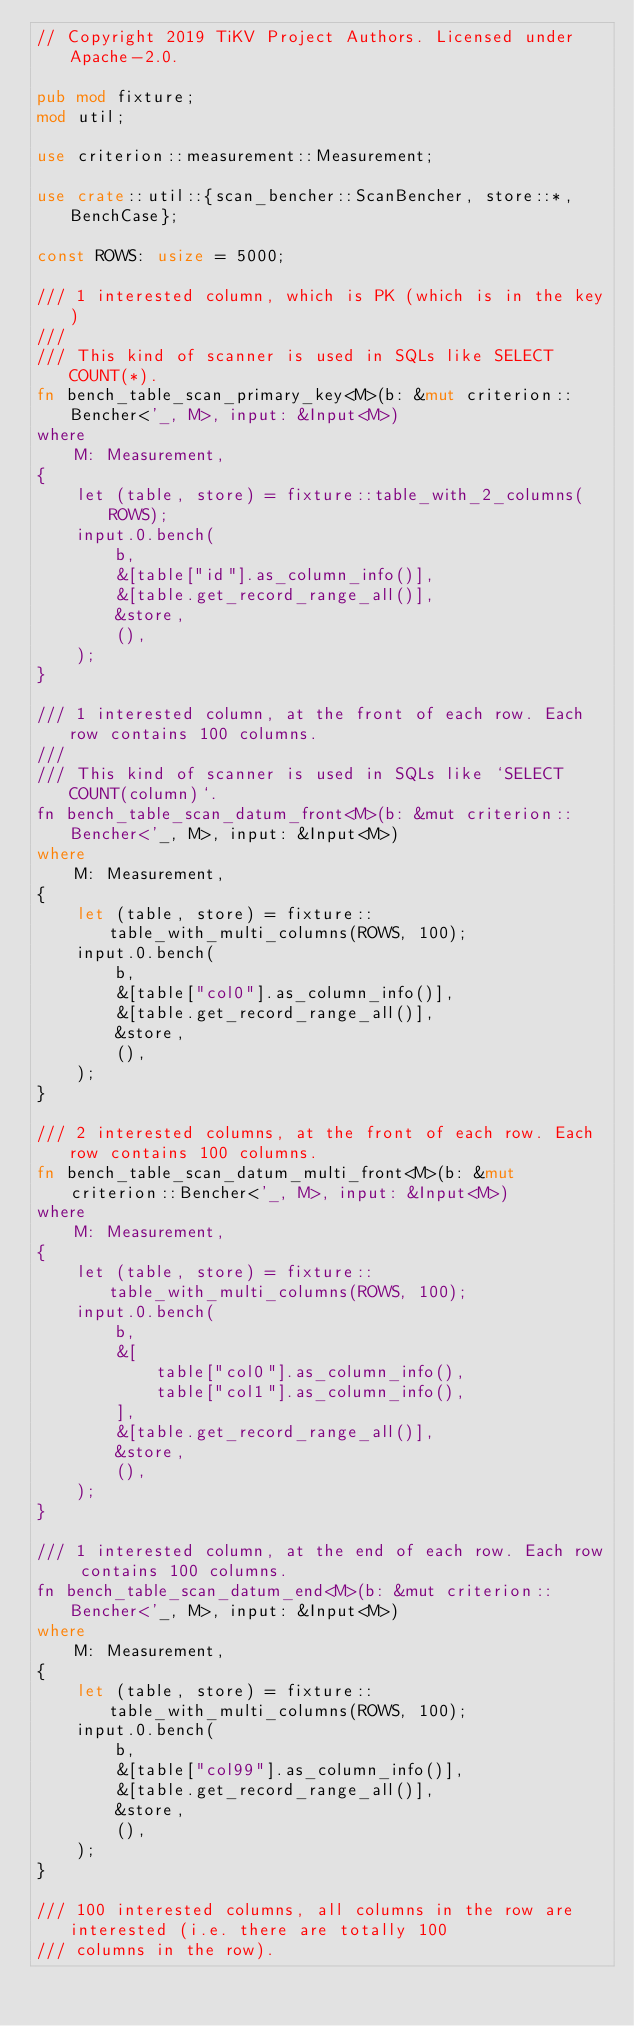Convert code to text. <code><loc_0><loc_0><loc_500><loc_500><_Rust_>// Copyright 2019 TiKV Project Authors. Licensed under Apache-2.0.

pub mod fixture;
mod util;

use criterion::measurement::Measurement;

use crate::util::{scan_bencher::ScanBencher, store::*, BenchCase};

const ROWS: usize = 5000;

/// 1 interested column, which is PK (which is in the key)
///
/// This kind of scanner is used in SQLs like SELECT COUNT(*).
fn bench_table_scan_primary_key<M>(b: &mut criterion::Bencher<'_, M>, input: &Input<M>)
where
    M: Measurement,
{
    let (table, store) = fixture::table_with_2_columns(ROWS);
    input.0.bench(
        b,
        &[table["id"].as_column_info()],
        &[table.get_record_range_all()],
        &store,
        (),
    );
}

/// 1 interested column, at the front of each row. Each row contains 100 columns.
///
/// This kind of scanner is used in SQLs like `SELECT COUNT(column)`.
fn bench_table_scan_datum_front<M>(b: &mut criterion::Bencher<'_, M>, input: &Input<M>)
where
    M: Measurement,
{
    let (table, store) = fixture::table_with_multi_columns(ROWS, 100);
    input.0.bench(
        b,
        &[table["col0"].as_column_info()],
        &[table.get_record_range_all()],
        &store,
        (),
    );
}

/// 2 interested columns, at the front of each row. Each row contains 100 columns.
fn bench_table_scan_datum_multi_front<M>(b: &mut criterion::Bencher<'_, M>, input: &Input<M>)
where
    M: Measurement,
{
    let (table, store) = fixture::table_with_multi_columns(ROWS, 100);
    input.0.bench(
        b,
        &[
            table["col0"].as_column_info(),
            table["col1"].as_column_info(),
        ],
        &[table.get_record_range_all()],
        &store,
        (),
    );
}

/// 1 interested column, at the end of each row. Each row contains 100 columns.
fn bench_table_scan_datum_end<M>(b: &mut criterion::Bencher<'_, M>, input: &Input<M>)
where
    M: Measurement,
{
    let (table, store) = fixture::table_with_multi_columns(ROWS, 100);
    input.0.bench(
        b,
        &[table["col99"].as_column_info()],
        &[table.get_record_range_all()],
        &store,
        (),
    );
}

/// 100 interested columns, all columns in the row are interested (i.e. there are totally 100
/// columns in the row).</code> 